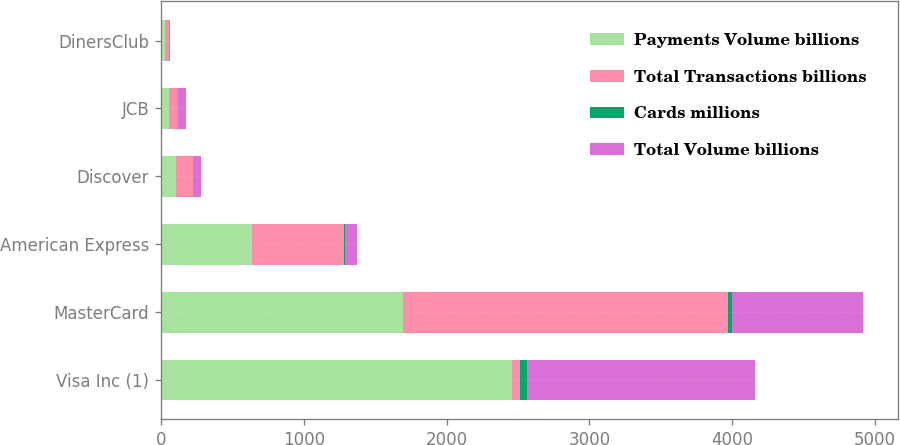Convert chart. <chart><loc_0><loc_0><loc_500><loc_500><stacked_bar_chart><ecel><fcel>Visa Inc (1)<fcel>MasterCard<fcel>American Express<fcel>Discover<fcel>JCB<fcel>DinersClub<nl><fcel>Payments Volume billions<fcel>2457<fcel>1697<fcel>637<fcel>102<fcel>55<fcel>29<nl><fcel>Total Transactions billions<fcel>58<fcel>2276<fcel>647<fcel>119<fcel>61<fcel>30<nl><fcel>Cards millions<fcel>50.3<fcel>27<fcel>5<fcel>1.6<fcel>0.6<fcel>0.2<nl><fcel>Total Volume billions<fcel>1592<fcel>916<fcel>86<fcel>57<fcel>58<fcel>7<nl></chart> 